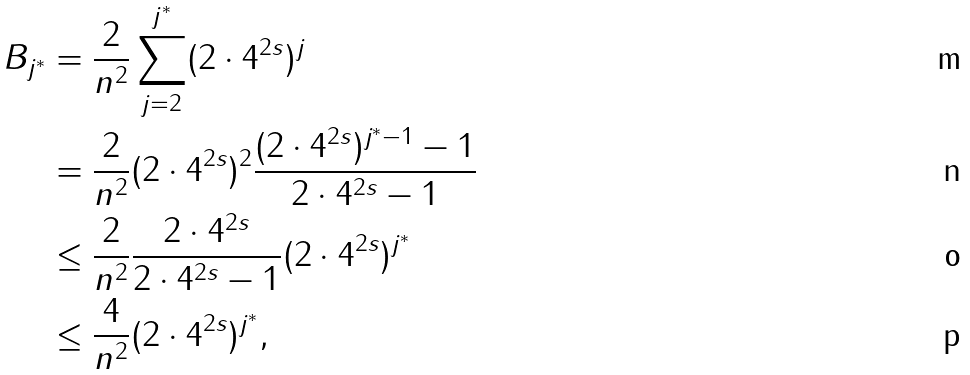Convert formula to latex. <formula><loc_0><loc_0><loc_500><loc_500>B _ { j ^ { \ast } } & = \frac { 2 } { n ^ { 2 } } \sum _ { j = 2 } ^ { j ^ { \ast } } ( 2 \cdot 4 ^ { 2 s } ) ^ { j } \\ & = \frac { 2 } { n ^ { 2 } } ( 2 \cdot 4 ^ { 2 s } ) ^ { 2 } \frac { ( 2 \cdot 4 ^ { 2 s } ) ^ { j ^ { \ast } - 1 } - 1 } { 2 \cdot 4 ^ { 2 s } - 1 } \\ & \leq \frac { 2 } { n ^ { 2 } } \frac { 2 \cdot 4 ^ { 2 s } } { 2 \cdot 4 ^ { 2 s } - 1 } ( 2 \cdot 4 ^ { 2 s } ) ^ { j ^ { \ast } } \\ & \leq \frac { 4 } { n ^ { 2 } } ( 2 \cdot 4 ^ { 2 s } ) ^ { j ^ { \ast } } ,</formula> 